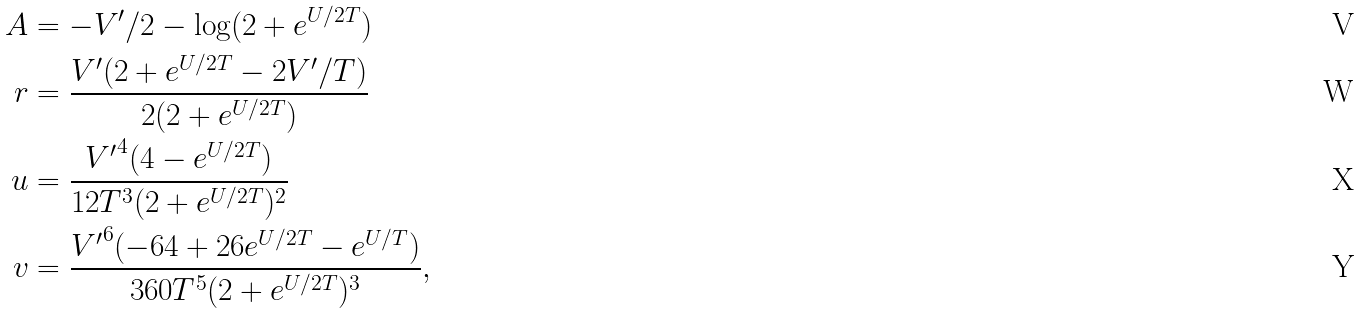<formula> <loc_0><loc_0><loc_500><loc_500>A & = - V ^ { \prime } / 2 - \log ( 2 + e ^ { U / 2 T } ) \\ r & = \frac { V ^ { \prime } ( 2 + e ^ { U / 2 T } - 2 V ^ { \prime } / T ) } { 2 ( 2 + e ^ { U / 2 T } ) } \\ u & = \frac { { V ^ { \prime } } ^ { 4 } ( 4 - e ^ { U / 2 T } ) } { 1 2 T ^ { 3 } ( 2 + e ^ { U / 2 T } ) ^ { 2 } } \\ v & = \frac { { V ^ { \prime } } ^ { 6 } ( - 6 4 + 2 6 e ^ { U / 2 T } - e ^ { U / T } ) } { 3 6 0 T ^ { 5 } ( 2 + e ^ { U / 2 T } ) ^ { 3 } } ,</formula> 